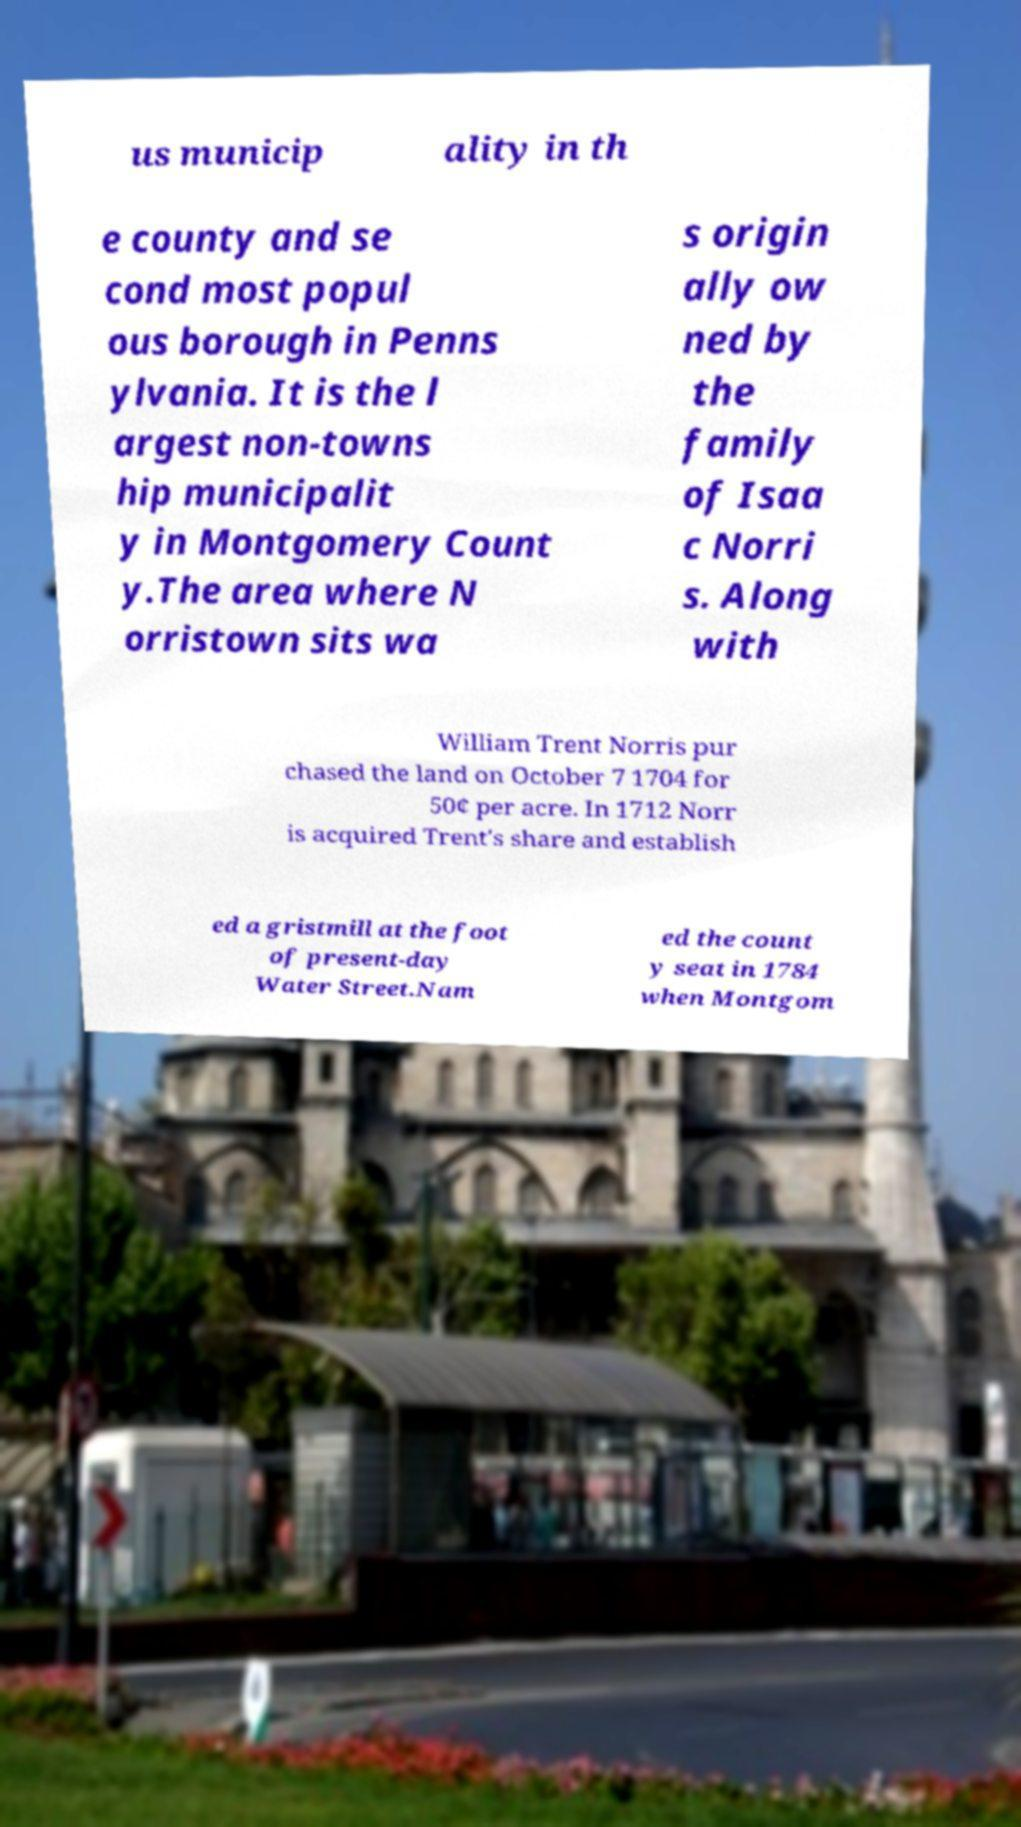For documentation purposes, I need the text within this image transcribed. Could you provide that? us municip ality in th e county and se cond most popul ous borough in Penns ylvania. It is the l argest non-towns hip municipalit y in Montgomery Count y.The area where N orristown sits wa s origin ally ow ned by the family of Isaa c Norri s. Along with William Trent Norris pur chased the land on October 7 1704 for 50¢ per acre. In 1712 Norr is acquired Trent's share and establish ed a gristmill at the foot of present-day Water Street.Nam ed the count y seat in 1784 when Montgom 